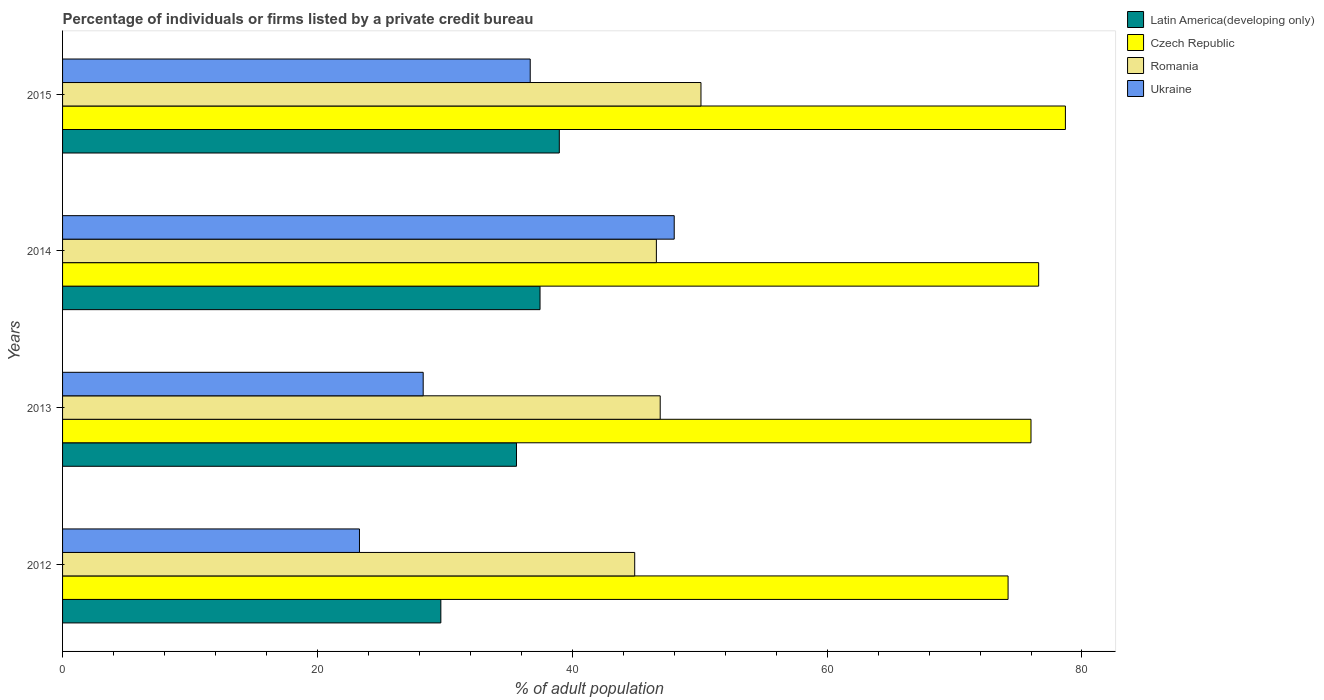Are the number of bars per tick equal to the number of legend labels?
Ensure brevity in your answer.  Yes. Are the number of bars on each tick of the Y-axis equal?
Your answer should be compact. Yes. How many bars are there on the 2nd tick from the top?
Ensure brevity in your answer.  4. How many bars are there on the 3rd tick from the bottom?
Ensure brevity in your answer.  4. In how many cases, is the number of bars for a given year not equal to the number of legend labels?
Give a very brief answer. 0. What is the percentage of population listed by a private credit bureau in Latin America(developing only) in 2013?
Give a very brief answer. 35.62. Across all years, what is the maximum percentage of population listed by a private credit bureau in Latin America(developing only)?
Provide a short and direct response. 38.98. Across all years, what is the minimum percentage of population listed by a private credit bureau in Ukraine?
Your response must be concise. 23.3. In which year was the percentage of population listed by a private credit bureau in Romania maximum?
Offer a very short reply. 2015. In which year was the percentage of population listed by a private credit bureau in Latin America(developing only) minimum?
Ensure brevity in your answer.  2012. What is the total percentage of population listed by a private credit bureau in Latin America(developing only) in the graph?
Your answer should be compact. 141.76. What is the difference between the percentage of population listed by a private credit bureau in Czech Republic in 2014 and that in 2015?
Your answer should be very brief. -2.1. What is the difference between the percentage of population listed by a private credit bureau in Romania in 2015 and the percentage of population listed by a private credit bureau in Latin America(developing only) in 2012?
Provide a short and direct response. 20.41. What is the average percentage of population listed by a private credit bureau in Romania per year?
Provide a succinct answer. 47.12. In the year 2012, what is the difference between the percentage of population listed by a private credit bureau in Ukraine and percentage of population listed by a private credit bureau in Romania?
Offer a terse response. -21.6. In how many years, is the percentage of population listed by a private credit bureau in Romania greater than 28 %?
Make the answer very short. 4. What is the ratio of the percentage of population listed by a private credit bureau in Latin America(developing only) in 2012 to that in 2013?
Offer a terse response. 0.83. What is the difference between the highest and the second highest percentage of population listed by a private credit bureau in Czech Republic?
Your response must be concise. 2.1. What is the difference between the highest and the lowest percentage of population listed by a private credit bureau in Romania?
Provide a short and direct response. 5.2. Is the sum of the percentage of population listed by a private credit bureau in Ukraine in 2012 and 2014 greater than the maximum percentage of population listed by a private credit bureau in Czech Republic across all years?
Ensure brevity in your answer.  No. What does the 4th bar from the top in 2013 represents?
Your response must be concise. Latin America(developing only). What does the 4th bar from the bottom in 2015 represents?
Your answer should be compact. Ukraine. Is it the case that in every year, the sum of the percentage of population listed by a private credit bureau in Ukraine and percentage of population listed by a private credit bureau in Latin America(developing only) is greater than the percentage of population listed by a private credit bureau in Czech Republic?
Offer a very short reply. No. Are all the bars in the graph horizontal?
Give a very brief answer. Yes. How many years are there in the graph?
Give a very brief answer. 4. Are the values on the major ticks of X-axis written in scientific E-notation?
Give a very brief answer. No. Does the graph contain any zero values?
Provide a short and direct response. No. Where does the legend appear in the graph?
Offer a very short reply. Top right. What is the title of the graph?
Your response must be concise. Percentage of individuals or firms listed by a private credit bureau. What is the label or title of the X-axis?
Keep it short and to the point. % of adult population. What is the % of adult population in Latin America(developing only) in 2012?
Give a very brief answer. 29.69. What is the % of adult population in Czech Republic in 2012?
Give a very brief answer. 74.2. What is the % of adult population in Romania in 2012?
Provide a succinct answer. 44.9. What is the % of adult population of Ukraine in 2012?
Offer a very short reply. 23.3. What is the % of adult population of Latin America(developing only) in 2013?
Your answer should be very brief. 35.62. What is the % of adult population in Romania in 2013?
Keep it short and to the point. 46.9. What is the % of adult population in Ukraine in 2013?
Ensure brevity in your answer.  28.3. What is the % of adult population of Latin America(developing only) in 2014?
Provide a succinct answer. 37.47. What is the % of adult population of Czech Republic in 2014?
Make the answer very short. 76.6. What is the % of adult population of Romania in 2014?
Your answer should be very brief. 46.6. What is the % of adult population in Latin America(developing only) in 2015?
Your answer should be compact. 38.98. What is the % of adult population of Czech Republic in 2015?
Your answer should be very brief. 78.7. What is the % of adult population of Romania in 2015?
Your answer should be compact. 50.1. What is the % of adult population of Ukraine in 2015?
Provide a short and direct response. 36.7. Across all years, what is the maximum % of adult population of Latin America(developing only)?
Provide a short and direct response. 38.98. Across all years, what is the maximum % of adult population in Czech Republic?
Give a very brief answer. 78.7. Across all years, what is the maximum % of adult population in Romania?
Provide a short and direct response. 50.1. Across all years, what is the minimum % of adult population in Latin America(developing only)?
Provide a short and direct response. 29.69. Across all years, what is the minimum % of adult population in Czech Republic?
Offer a very short reply. 74.2. Across all years, what is the minimum % of adult population of Romania?
Offer a very short reply. 44.9. Across all years, what is the minimum % of adult population of Ukraine?
Give a very brief answer. 23.3. What is the total % of adult population of Latin America(developing only) in the graph?
Your answer should be compact. 141.76. What is the total % of adult population of Czech Republic in the graph?
Provide a succinct answer. 305.5. What is the total % of adult population of Romania in the graph?
Your answer should be compact. 188.5. What is the total % of adult population in Ukraine in the graph?
Give a very brief answer. 136.3. What is the difference between the % of adult population in Latin America(developing only) in 2012 and that in 2013?
Offer a terse response. -5.94. What is the difference between the % of adult population of Czech Republic in 2012 and that in 2013?
Provide a short and direct response. -1.8. What is the difference between the % of adult population in Latin America(developing only) in 2012 and that in 2014?
Your answer should be compact. -7.78. What is the difference between the % of adult population of Czech Republic in 2012 and that in 2014?
Ensure brevity in your answer.  -2.4. What is the difference between the % of adult population in Romania in 2012 and that in 2014?
Your answer should be very brief. -1.7. What is the difference between the % of adult population in Ukraine in 2012 and that in 2014?
Make the answer very short. -24.7. What is the difference between the % of adult population of Latin America(developing only) in 2012 and that in 2015?
Offer a very short reply. -9.3. What is the difference between the % of adult population of Czech Republic in 2012 and that in 2015?
Keep it short and to the point. -4.5. What is the difference between the % of adult population in Latin America(developing only) in 2013 and that in 2014?
Your answer should be very brief. -1.85. What is the difference between the % of adult population in Czech Republic in 2013 and that in 2014?
Your response must be concise. -0.6. What is the difference between the % of adult population of Romania in 2013 and that in 2014?
Offer a very short reply. 0.3. What is the difference between the % of adult population of Ukraine in 2013 and that in 2014?
Your answer should be very brief. -19.7. What is the difference between the % of adult population of Latin America(developing only) in 2013 and that in 2015?
Provide a succinct answer. -3.36. What is the difference between the % of adult population in Ukraine in 2013 and that in 2015?
Your answer should be very brief. -8.4. What is the difference between the % of adult population in Latin America(developing only) in 2014 and that in 2015?
Your answer should be compact. -1.51. What is the difference between the % of adult population in Romania in 2014 and that in 2015?
Your answer should be compact. -3.5. What is the difference between the % of adult population in Latin America(developing only) in 2012 and the % of adult population in Czech Republic in 2013?
Make the answer very short. -46.31. What is the difference between the % of adult population in Latin America(developing only) in 2012 and the % of adult population in Romania in 2013?
Provide a succinct answer. -17.21. What is the difference between the % of adult population of Latin America(developing only) in 2012 and the % of adult population of Ukraine in 2013?
Offer a terse response. 1.39. What is the difference between the % of adult population in Czech Republic in 2012 and the % of adult population in Romania in 2013?
Your response must be concise. 27.3. What is the difference between the % of adult population in Czech Republic in 2012 and the % of adult population in Ukraine in 2013?
Your answer should be very brief. 45.9. What is the difference between the % of adult population in Romania in 2012 and the % of adult population in Ukraine in 2013?
Keep it short and to the point. 16.6. What is the difference between the % of adult population in Latin America(developing only) in 2012 and the % of adult population in Czech Republic in 2014?
Give a very brief answer. -46.91. What is the difference between the % of adult population of Latin America(developing only) in 2012 and the % of adult population of Romania in 2014?
Provide a short and direct response. -16.91. What is the difference between the % of adult population in Latin America(developing only) in 2012 and the % of adult population in Ukraine in 2014?
Your answer should be compact. -18.31. What is the difference between the % of adult population of Czech Republic in 2012 and the % of adult population of Romania in 2014?
Provide a short and direct response. 27.6. What is the difference between the % of adult population of Czech Republic in 2012 and the % of adult population of Ukraine in 2014?
Ensure brevity in your answer.  26.2. What is the difference between the % of adult population of Romania in 2012 and the % of adult population of Ukraine in 2014?
Make the answer very short. -3.1. What is the difference between the % of adult population in Latin America(developing only) in 2012 and the % of adult population in Czech Republic in 2015?
Ensure brevity in your answer.  -49.01. What is the difference between the % of adult population in Latin America(developing only) in 2012 and the % of adult population in Romania in 2015?
Give a very brief answer. -20.41. What is the difference between the % of adult population in Latin America(developing only) in 2012 and the % of adult population in Ukraine in 2015?
Your answer should be very brief. -7.01. What is the difference between the % of adult population of Czech Republic in 2012 and the % of adult population of Romania in 2015?
Your answer should be very brief. 24.1. What is the difference between the % of adult population of Czech Republic in 2012 and the % of adult population of Ukraine in 2015?
Your answer should be compact. 37.5. What is the difference between the % of adult population in Romania in 2012 and the % of adult population in Ukraine in 2015?
Your answer should be compact. 8.2. What is the difference between the % of adult population of Latin America(developing only) in 2013 and the % of adult population of Czech Republic in 2014?
Your answer should be compact. -40.98. What is the difference between the % of adult population of Latin America(developing only) in 2013 and the % of adult population of Romania in 2014?
Your answer should be compact. -10.98. What is the difference between the % of adult population of Latin America(developing only) in 2013 and the % of adult population of Ukraine in 2014?
Your response must be concise. -12.38. What is the difference between the % of adult population in Czech Republic in 2013 and the % of adult population in Romania in 2014?
Offer a terse response. 29.4. What is the difference between the % of adult population in Latin America(developing only) in 2013 and the % of adult population in Czech Republic in 2015?
Offer a terse response. -43.08. What is the difference between the % of adult population in Latin America(developing only) in 2013 and the % of adult population in Romania in 2015?
Your response must be concise. -14.48. What is the difference between the % of adult population of Latin America(developing only) in 2013 and the % of adult population of Ukraine in 2015?
Make the answer very short. -1.08. What is the difference between the % of adult population of Czech Republic in 2013 and the % of adult population of Romania in 2015?
Offer a very short reply. 25.9. What is the difference between the % of adult population of Czech Republic in 2013 and the % of adult population of Ukraine in 2015?
Keep it short and to the point. 39.3. What is the difference between the % of adult population of Latin America(developing only) in 2014 and the % of adult population of Czech Republic in 2015?
Offer a terse response. -41.23. What is the difference between the % of adult population of Latin America(developing only) in 2014 and the % of adult population of Romania in 2015?
Offer a very short reply. -12.63. What is the difference between the % of adult population in Latin America(developing only) in 2014 and the % of adult population in Ukraine in 2015?
Provide a succinct answer. 0.77. What is the difference between the % of adult population in Czech Republic in 2014 and the % of adult population in Romania in 2015?
Offer a very short reply. 26.5. What is the difference between the % of adult population in Czech Republic in 2014 and the % of adult population in Ukraine in 2015?
Offer a very short reply. 39.9. What is the difference between the % of adult population in Romania in 2014 and the % of adult population in Ukraine in 2015?
Provide a succinct answer. 9.9. What is the average % of adult population in Latin America(developing only) per year?
Make the answer very short. 35.44. What is the average % of adult population of Czech Republic per year?
Keep it short and to the point. 76.38. What is the average % of adult population of Romania per year?
Make the answer very short. 47.12. What is the average % of adult population in Ukraine per year?
Ensure brevity in your answer.  34.08. In the year 2012, what is the difference between the % of adult population in Latin America(developing only) and % of adult population in Czech Republic?
Ensure brevity in your answer.  -44.51. In the year 2012, what is the difference between the % of adult population of Latin America(developing only) and % of adult population of Romania?
Give a very brief answer. -15.21. In the year 2012, what is the difference between the % of adult population of Latin America(developing only) and % of adult population of Ukraine?
Provide a succinct answer. 6.39. In the year 2012, what is the difference between the % of adult population of Czech Republic and % of adult population of Romania?
Your answer should be very brief. 29.3. In the year 2012, what is the difference between the % of adult population of Czech Republic and % of adult population of Ukraine?
Provide a succinct answer. 50.9. In the year 2012, what is the difference between the % of adult population in Romania and % of adult population in Ukraine?
Give a very brief answer. 21.6. In the year 2013, what is the difference between the % of adult population of Latin America(developing only) and % of adult population of Czech Republic?
Your response must be concise. -40.38. In the year 2013, what is the difference between the % of adult population of Latin America(developing only) and % of adult population of Romania?
Provide a succinct answer. -11.28. In the year 2013, what is the difference between the % of adult population in Latin America(developing only) and % of adult population in Ukraine?
Your response must be concise. 7.32. In the year 2013, what is the difference between the % of adult population of Czech Republic and % of adult population of Romania?
Offer a very short reply. 29.1. In the year 2013, what is the difference between the % of adult population of Czech Republic and % of adult population of Ukraine?
Offer a terse response. 47.7. In the year 2014, what is the difference between the % of adult population in Latin America(developing only) and % of adult population in Czech Republic?
Make the answer very short. -39.13. In the year 2014, what is the difference between the % of adult population in Latin America(developing only) and % of adult population in Romania?
Provide a short and direct response. -9.13. In the year 2014, what is the difference between the % of adult population in Latin America(developing only) and % of adult population in Ukraine?
Offer a terse response. -10.53. In the year 2014, what is the difference between the % of adult population of Czech Republic and % of adult population of Romania?
Give a very brief answer. 30. In the year 2014, what is the difference between the % of adult population in Czech Republic and % of adult population in Ukraine?
Make the answer very short. 28.6. In the year 2015, what is the difference between the % of adult population in Latin America(developing only) and % of adult population in Czech Republic?
Make the answer very short. -39.72. In the year 2015, what is the difference between the % of adult population of Latin America(developing only) and % of adult population of Romania?
Provide a succinct answer. -11.12. In the year 2015, what is the difference between the % of adult population in Latin America(developing only) and % of adult population in Ukraine?
Your response must be concise. 2.28. In the year 2015, what is the difference between the % of adult population in Czech Republic and % of adult population in Romania?
Provide a short and direct response. 28.6. In the year 2015, what is the difference between the % of adult population in Czech Republic and % of adult population in Ukraine?
Provide a short and direct response. 42. In the year 2015, what is the difference between the % of adult population in Romania and % of adult population in Ukraine?
Offer a very short reply. 13.4. What is the ratio of the % of adult population in Latin America(developing only) in 2012 to that in 2013?
Provide a short and direct response. 0.83. What is the ratio of the % of adult population in Czech Republic in 2012 to that in 2013?
Provide a succinct answer. 0.98. What is the ratio of the % of adult population of Romania in 2012 to that in 2013?
Offer a terse response. 0.96. What is the ratio of the % of adult population in Ukraine in 2012 to that in 2013?
Your answer should be very brief. 0.82. What is the ratio of the % of adult population of Latin America(developing only) in 2012 to that in 2014?
Provide a short and direct response. 0.79. What is the ratio of the % of adult population in Czech Republic in 2012 to that in 2014?
Give a very brief answer. 0.97. What is the ratio of the % of adult population in Romania in 2012 to that in 2014?
Offer a terse response. 0.96. What is the ratio of the % of adult population of Ukraine in 2012 to that in 2014?
Offer a terse response. 0.49. What is the ratio of the % of adult population of Latin America(developing only) in 2012 to that in 2015?
Keep it short and to the point. 0.76. What is the ratio of the % of adult population in Czech Republic in 2012 to that in 2015?
Offer a terse response. 0.94. What is the ratio of the % of adult population of Romania in 2012 to that in 2015?
Your answer should be very brief. 0.9. What is the ratio of the % of adult population of Ukraine in 2012 to that in 2015?
Provide a succinct answer. 0.63. What is the ratio of the % of adult population in Latin America(developing only) in 2013 to that in 2014?
Ensure brevity in your answer.  0.95. What is the ratio of the % of adult population in Romania in 2013 to that in 2014?
Offer a very short reply. 1.01. What is the ratio of the % of adult population in Ukraine in 2013 to that in 2014?
Ensure brevity in your answer.  0.59. What is the ratio of the % of adult population of Latin America(developing only) in 2013 to that in 2015?
Give a very brief answer. 0.91. What is the ratio of the % of adult population in Czech Republic in 2013 to that in 2015?
Provide a succinct answer. 0.97. What is the ratio of the % of adult population of Romania in 2013 to that in 2015?
Keep it short and to the point. 0.94. What is the ratio of the % of adult population in Ukraine in 2013 to that in 2015?
Offer a very short reply. 0.77. What is the ratio of the % of adult population in Latin America(developing only) in 2014 to that in 2015?
Ensure brevity in your answer.  0.96. What is the ratio of the % of adult population in Czech Republic in 2014 to that in 2015?
Make the answer very short. 0.97. What is the ratio of the % of adult population of Romania in 2014 to that in 2015?
Your response must be concise. 0.93. What is the ratio of the % of adult population of Ukraine in 2014 to that in 2015?
Provide a short and direct response. 1.31. What is the difference between the highest and the second highest % of adult population of Latin America(developing only)?
Offer a terse response. 1.51. What is the difference between the highest and the second highest % of adult population in Czech Republic?
Provide a succinct answer. 2.1. What is the difference between the highest and the lowest % of adult population of Latin America(developing only)?
Your answer should be very brief. 9.3. What is the difference between the highest and the lowest % of adult population of Czech Republic?
Provide a succinct answer. 4.5. What is the difference between the highest and the lowest % of adult population of Ukraine?
Ensure brevity in your answer.  24.7. 